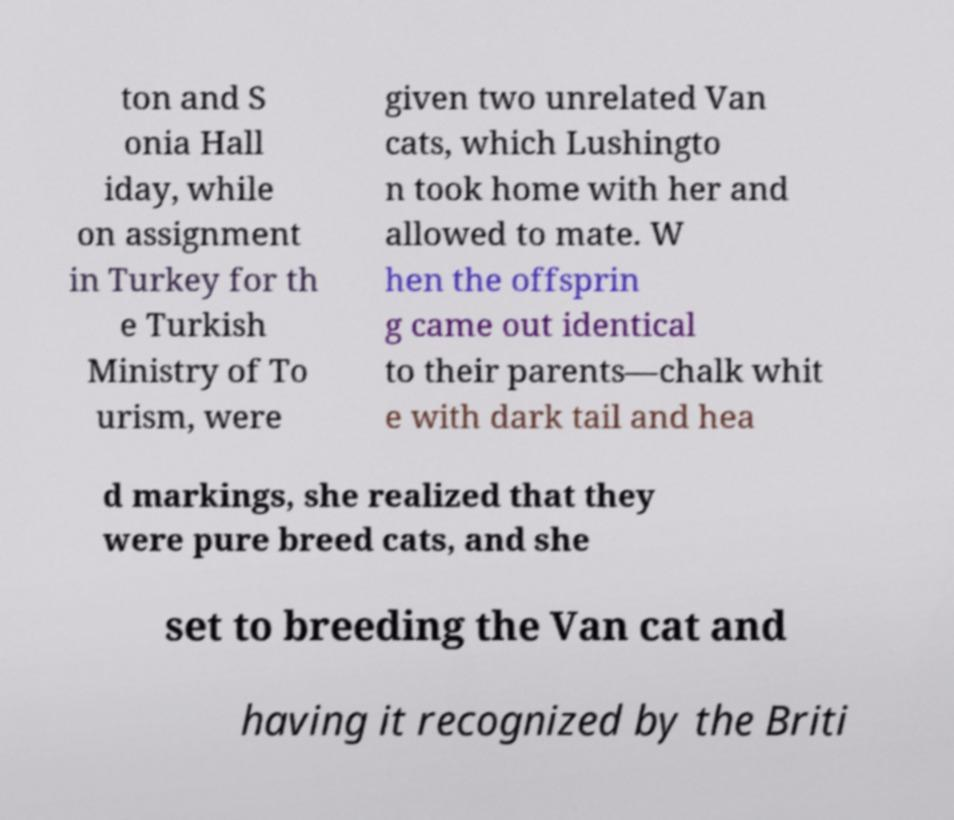Can you accurately transcribe the text from the provided image for me? ton and S onia Hall iday, while on assignment in Turkey for th e Turkish Ministry of To urism, were given two unrelated Van cats, which Lushingto n took home with her and allowed to mate. W hen the offsprin g came out identical to their parents—chalk whit e with dark tail and hea d markings, she realized that they were pure breed cats, and she set to breeding the Van cat and having it recognized by the Briti 